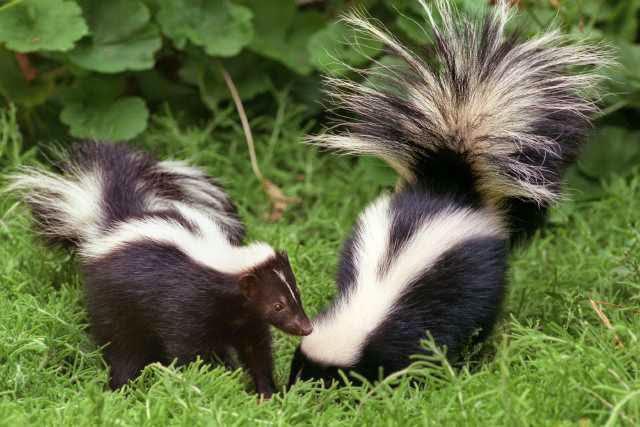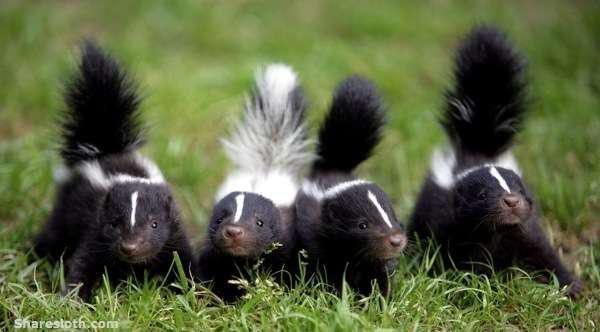The first image is the image on the left, the second image is the image on the right. Examine the images to the left and right. Is the description "An image shows a row of at least three skunks with their bodies turned forward, and at least one has its tail raised." accurate? Answer yes or no. Yes. 